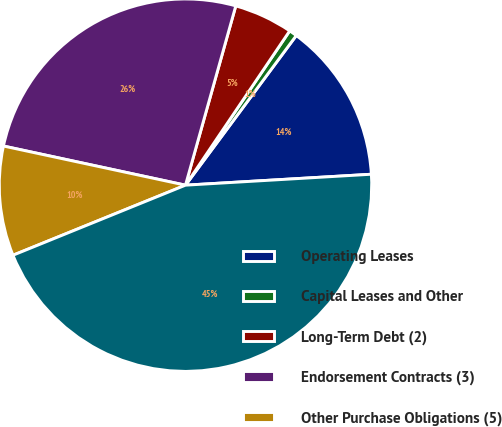Convert chart. <chart><loc_0><loc_0><loc_500><loc_500><pie_chart><fcel>Operating Leases<fcel>Capital Leases and Other<fcel>Long-Term Debt (2)<fcel>Endorsement Contracts (3)<fcel>Other Purchase Obligations (5)<fcel>TOTAL<nl><fcel>13.92%<fcel>0.69%<fcel>5.1%<fcel>25.98%<fcel>9.51%<fcel>44.79%<nl></chart> 